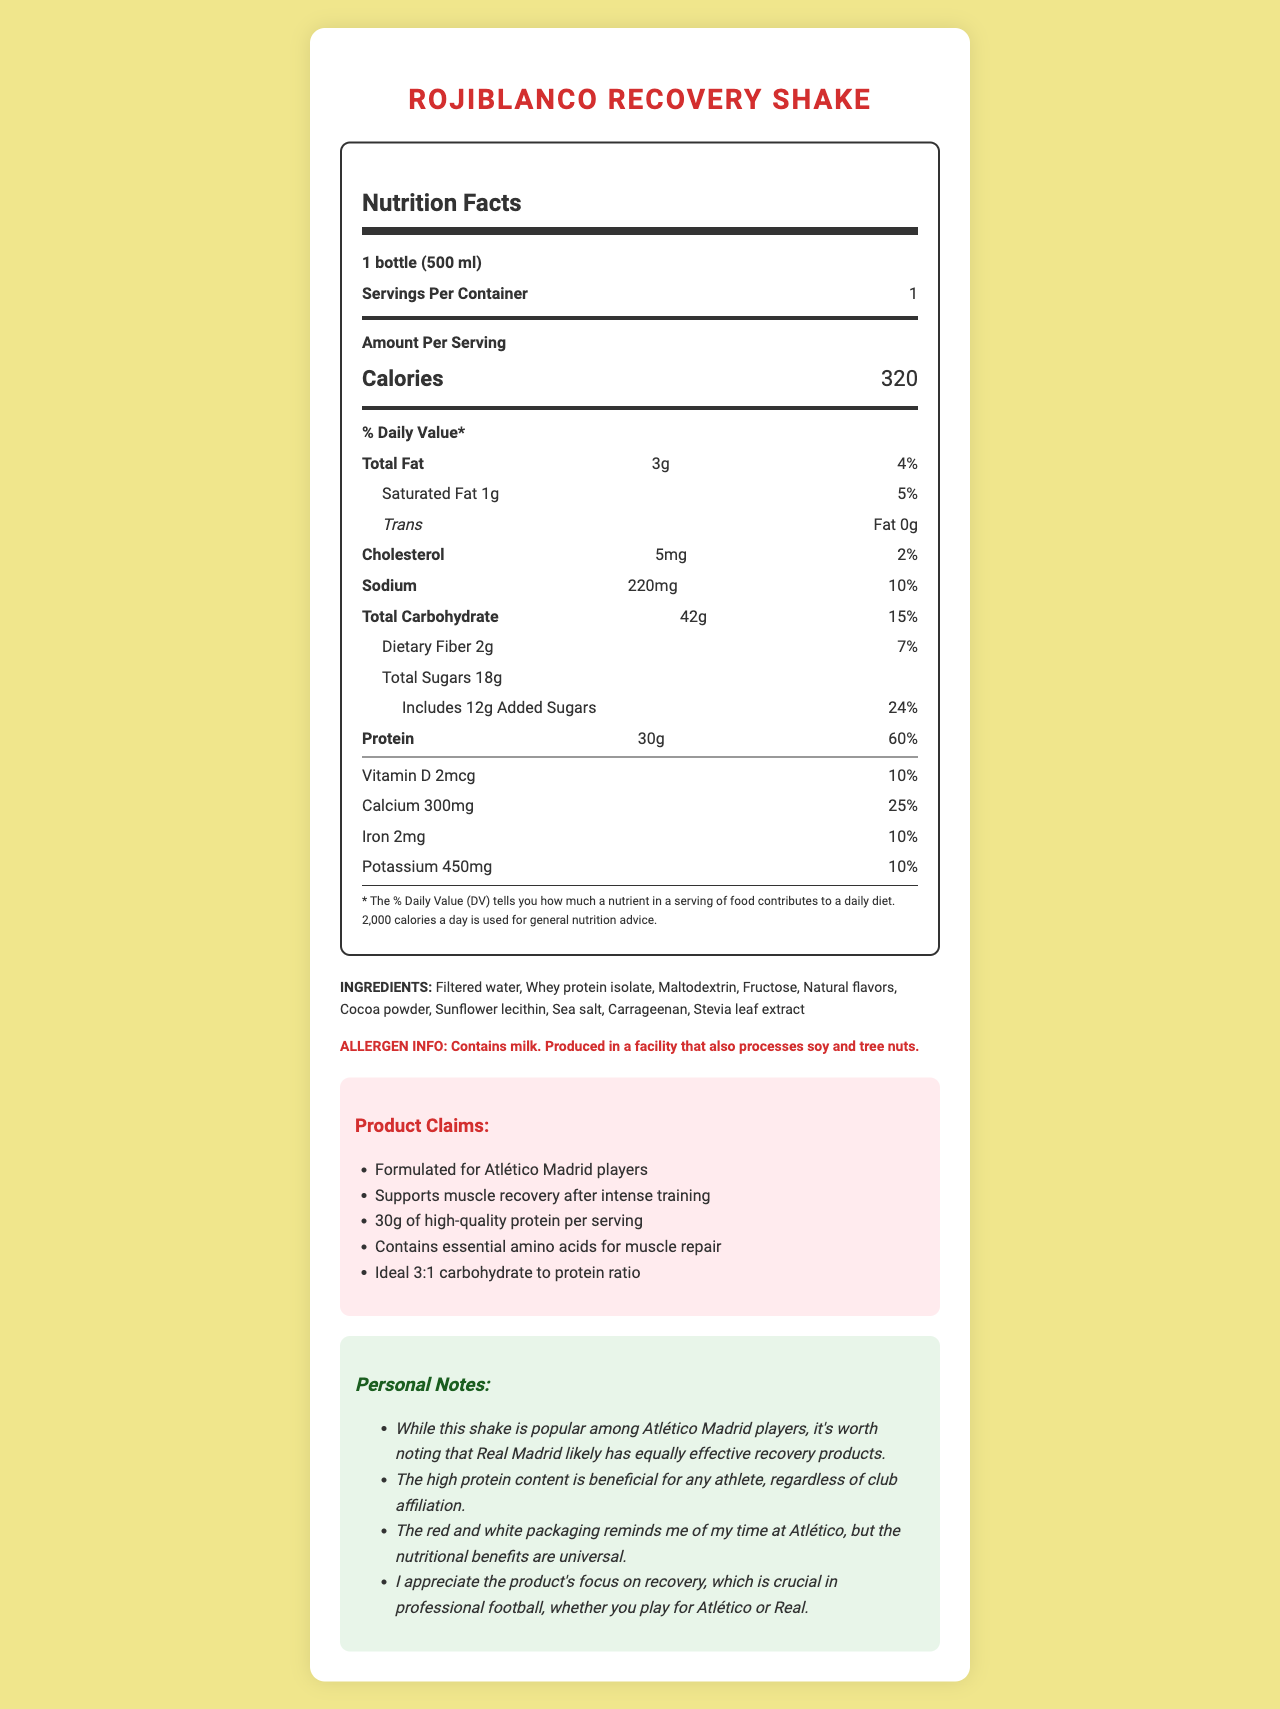what is the serving size? The document clearly states the serving size as "1 bottle (500 ml)".
Answer: 1 bottle (500 ml) how many calories does one serving contain? The document indicates that one serving contains 320 calories.
Answer: 320 calories What is the amount of added sugars per serving? The section on added sugars lists the amount as 12g.
Answer: 12g what is the primary source of protein in this shake? The ingredients list shows "Whey protein isolate" as one of the primary ingredients, which is typically high in protein.
Answer: Whey protein isolate how much sodium does the shake contain? The nutrition facts state that the shake contains 220mg of sodium.
Answer: 220mg which ingredient is used as a sweetener in the shake? A. Sugar B. Stevia leaf extract C. Aspartame D. High fructose corn syrup The ingredient list mentions "Stevia leaf extract" as the sweetener used.
Answer: B how many vitamins and minerals are listed on the label? A. 2 B. 3 C. 4 D. 5 The document lists four: Vitamin D, Calcium, Iron, and Potassium.
Answer: C Does the product contain any allergens? The allergen information states the product "Contains milk. Produced in a facility that also processes soy and tree nuts."
Answer: Yes Is it possible to determine how effective the product is compared to other recovery shakes? The document only provides nutritional information and marketing claims but doesn't offer comparative data against other products.
Answer: Not enough information Summarize the main idea of the document. The document outlines the nutritional facts, ingredients, allergen information, and marketing claims for the "Rojiblanco Recovery Shake," emphasizing its suitability for muscle recovery and its association with Atlético Madrid players.
Answer: The "Rojiblanco Recovery Shake" is a high-protein recovery drink designed for Atlético Madrid players, featuring 30g of protein per serving and a balanced ratio of carbohydrates and protein. It includes key nutrients and potential allergens, with a specific focus on muscle recovery. 